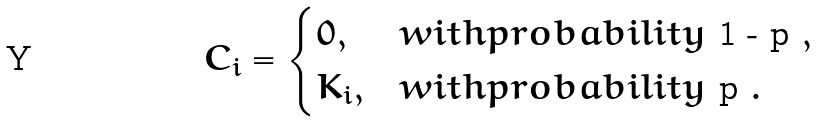Convert formula to latex. <formula><loc_0><loc_0><loc_500><loc_500>C _ { i } = \begin{cases} 0 , & w i t h p r o b a b i l i t y $ 1 - p $ , \\ K _ { i } , & w i t h p r o b a b i l i t y $ p $ . \end{cases}</formula> 